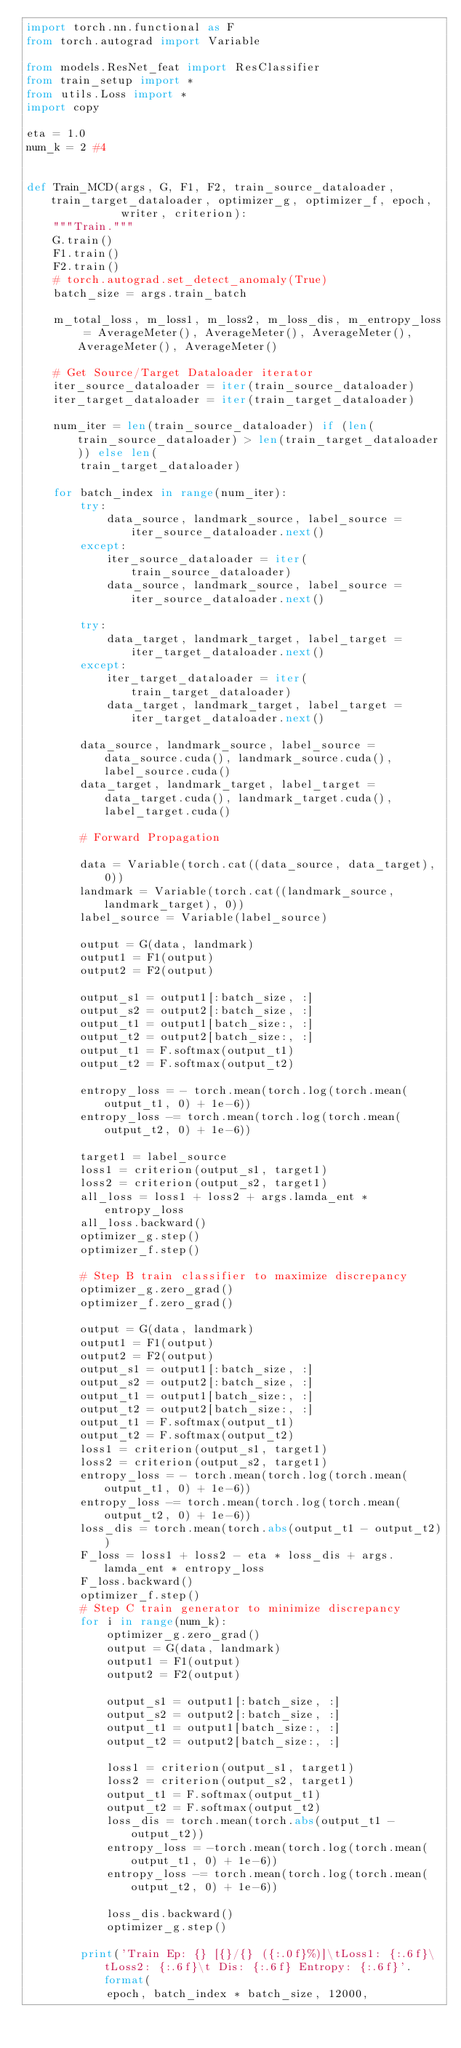Convert code to text. <code><loc_0><loc_0><loc_500><loc_500><_Python_>import torch.nn.functional as F
from torch.autograd import Variable

from models.ResNet_feat import ResClassifier
from train_setup import *
from utils.Loss import *
import copy

eta = 1.0
num_k = 2 #4


def Train_MCD(args, G, F1, F2, train_source_dataloader, train_target_dataloader, optimizer_g, optimizer_f, epoch,
              writer, criterion):
    """Train."""
    G.train()
    F1.train()
    F2.train()
    # torch.autograd.set_detect_anomaly(True)
    batch_size = args.train_batch

    m_total_loss, m_loss1, m_loss2, m_loss_dis, m_entropy_loss = AverageMeter(), AverageMeter(), AverageMeter(), AverageMeter(), AverageMeter()

    # Get Source/Target Dataloader iterator
    iter_source_dataloader = iter(train_source_dataloader)
    iter_target_dataloader = iter(train_target_dataloader)

    num_iter = len(train_source_dataloader) if (len(train_source_dataloader) > len(train_target_dataloader)) else len(
        train_target_dataloader)

    for batch_index in range(num_iter):
        try:
            data_source, landmark_source, label_source = iter_source_dataloader.next()
        except:
            iter_source_dataloader = iter(train_source_dataloader)
            data_source, landmark_source, label_source = iter_source_dataloader.next()

        try:
            data_target, landmark_target, label_target = iter_target_dataloader.next()
        except:
            iter_target_dataloader = iter(train_target_dataloader)
            data_target, landmark_target, label_target = iter_target_dataloader.next()

        data_source, landmark_source, label_source = data_source.cuda(), landmark_source.cuda(), label_source.cuda()
        data_target, landmark_target, label_target = data_target.cuda(), landmark_target.cuda(), label_target.cuda()

        # Forward Propagation

        data = Variable(torch.cat((data_source, data_target), 0))
        landmark = Variable(torch.cat((landmark_source, landmark_target), 0))
        label_source = Variable(label_source)

        output = G(data, landmark)
        output1 = F1(output)
        output2 = F2(output)

        output_s1 = output1[:batch_size, :]
        output_s2 = output2[:batch_size, :]
        output_t1 = output1[batch_size:, :]
        output_t2 = output2[batch_size:, :]
        output_t1 = F.softmax(output_t1)
        output_t2 = F.softmax(output_t2)

        entropy_loss = - torch.mean(torch.log(torch.mean(output_t1, 0) + 1e-6))
        entropy_loss -= torch.mean(torch.log(torch.mean(output_t2, 0) + 1e-6))

        target1 = label_source
        loss1 = criterion(output_s1, target1)
        loss2 = criterion(output_s2, target1)
        all_loss = loss1 + loss2 + args.lamda_ent * entropy_loss
        all_loss.backward()
        optimizer_g.step()
        optimizer_f.step()

        # Step B train classifier to maximize discrepancy
        optimizer_g.zero_grad()
        optimizer_f.zero_grad()

        output = G(data, landmark)
        output1 = F1(output)
        output2 = F2(output)
        output_s1 = output1[:batch_size, :]
        output_s2 = output2[:batch_size, :]
        output_t1 = output1[batch_size:, :]
        output_t2 = output2[batch_size:, :]
        output_t1 = F.softmax(output_t1)
        output_t2 = F.softmax(output_t2)
        loss1 = criterion(output_s1, target1)
        loss2 = criterion(output_s2, target1)
        entropy_loss = - torch.mean(torch.log(torch.mean(output_t1, 0) + 1e-6))
        entropy_loss -= torch.mean(torch.log(torch.mean(output_t2, 0) + 1e-6))
        loss_dis = torch.mean(torch.abs(output_t1 - output_t2))
        F_loss = loss1 + loss2 - eta * loss_dis + args.lamda_ent * entropy_loss
        F_loss.backward()
        optimizer_f.step()
        # Step C train generator to minimize discrepancy
        for i in range(num_k):
            optimizer_g.zero_grad()
            output = G(data, landmark)
            output1 = F1(output)
            output2 = F2(output)

            output_s1 = output1[:batch_size, :]
            output_s2 = output2[:batch_size, :]
            output_t1 = output1[batch_size:, :]
            output_t2 = output2[batch_size:, :]

            loss1 = criterion(output_s1, target1)
            loss2 = criterion(output_s2, target1)
            output_t1 = F.softmax(output_t1)
            output_t2 = F.softmax(output_t2)
            loss_dis = torch.mean(torch.abs(output_t1 - output_t2))
            entropy_loss = -torch.mean(torch.log(torch.mean(output_t1, 0) + 1e-6))
            entropy_loss -= torch.mean(torch.log(torch.mean(output_t2, 0) + 1e-6))

            loss_dis.backward()
            optimizer_g.step()

        print('Train Ep: {} [{}/{} ({:.0f}%)]\tLoss1: {:.6f}\tLoss2: {:.6f}\t Dis: {:.6f} Entropy: {:.6f}'.format(
            epoch, batch_index * batch_size, 12000,</code> 